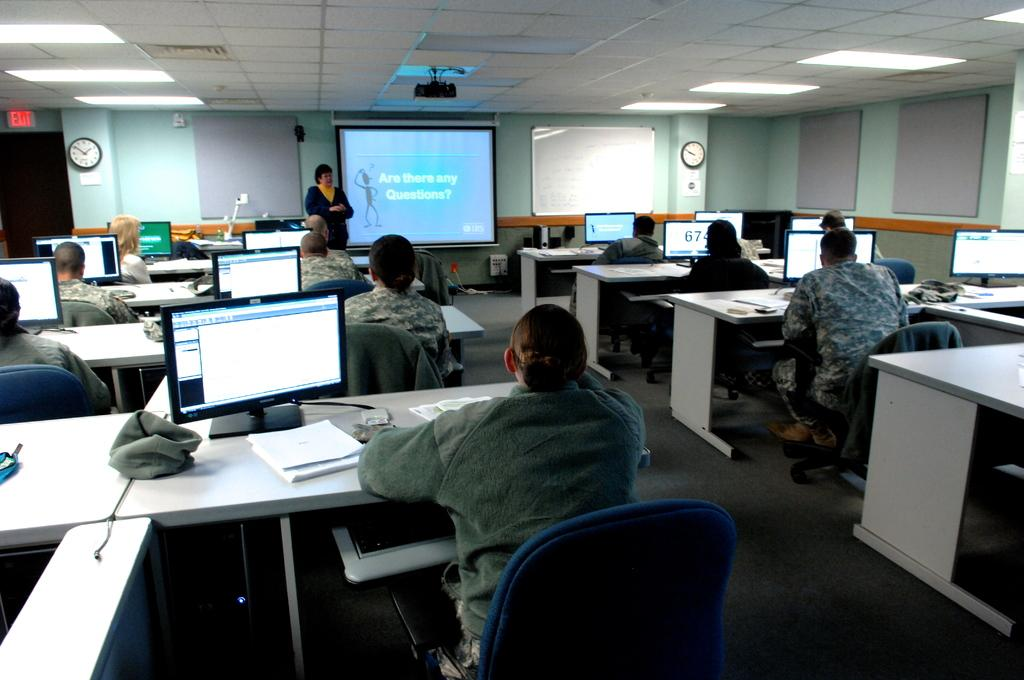Provide a one-sentence caption for the provided image. A woman is ready to take questions at the office meeting. 